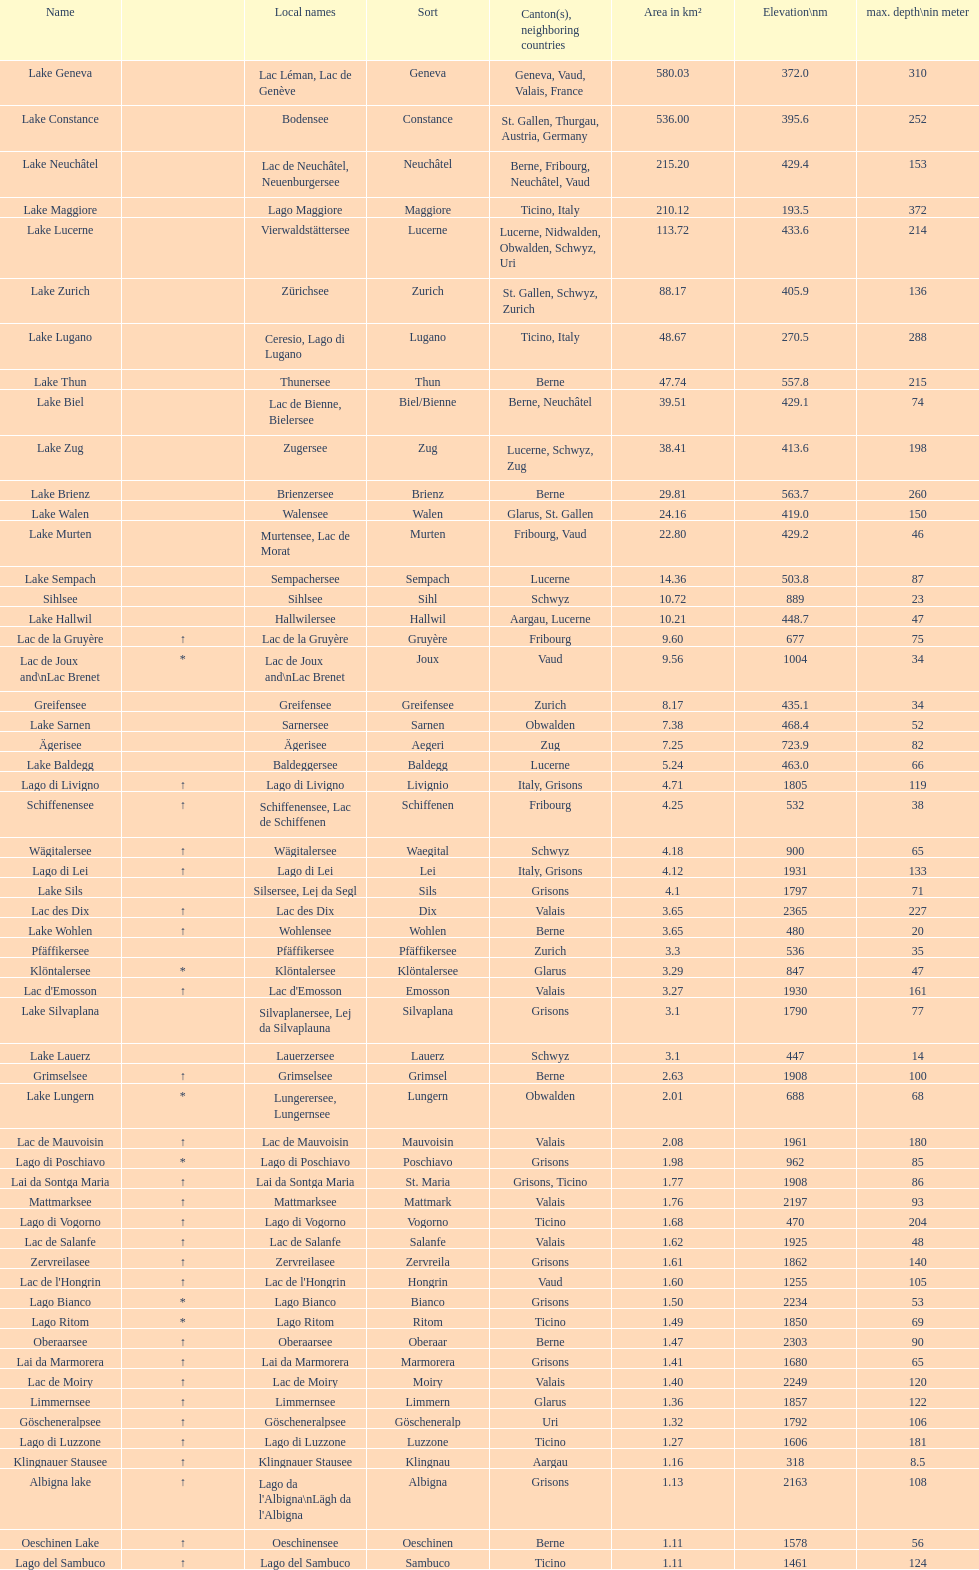Which lake possesses the highest elevation? Lac des Dix. 